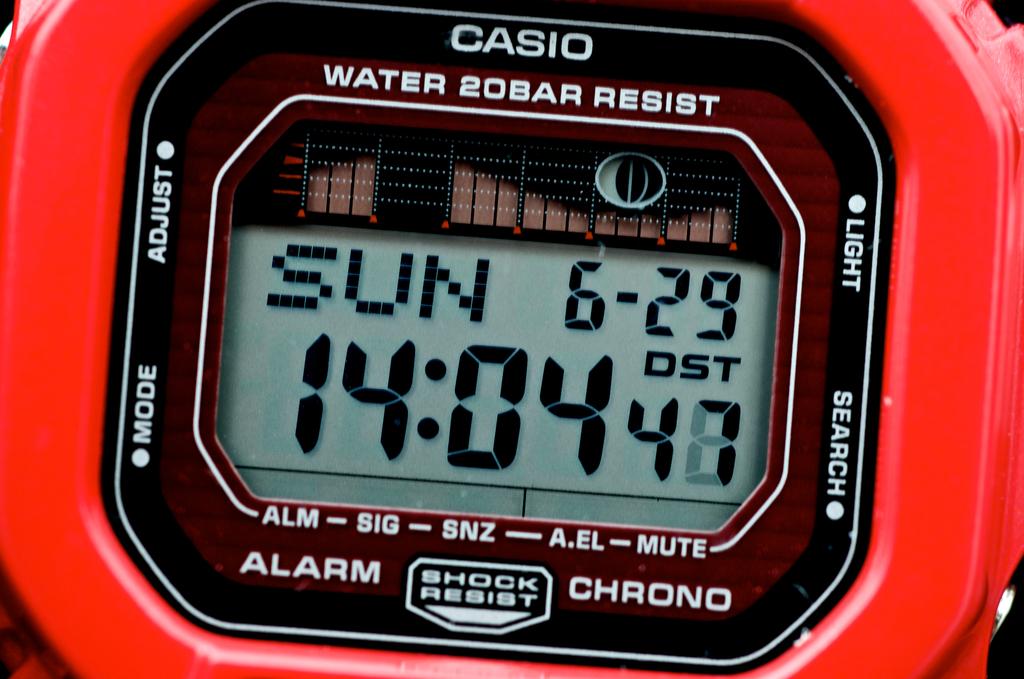What day of the week does the watch display?
Offer a terse response. Sunday. What brand of watch is this?
Ensure brevity in your answer.  Casio. 